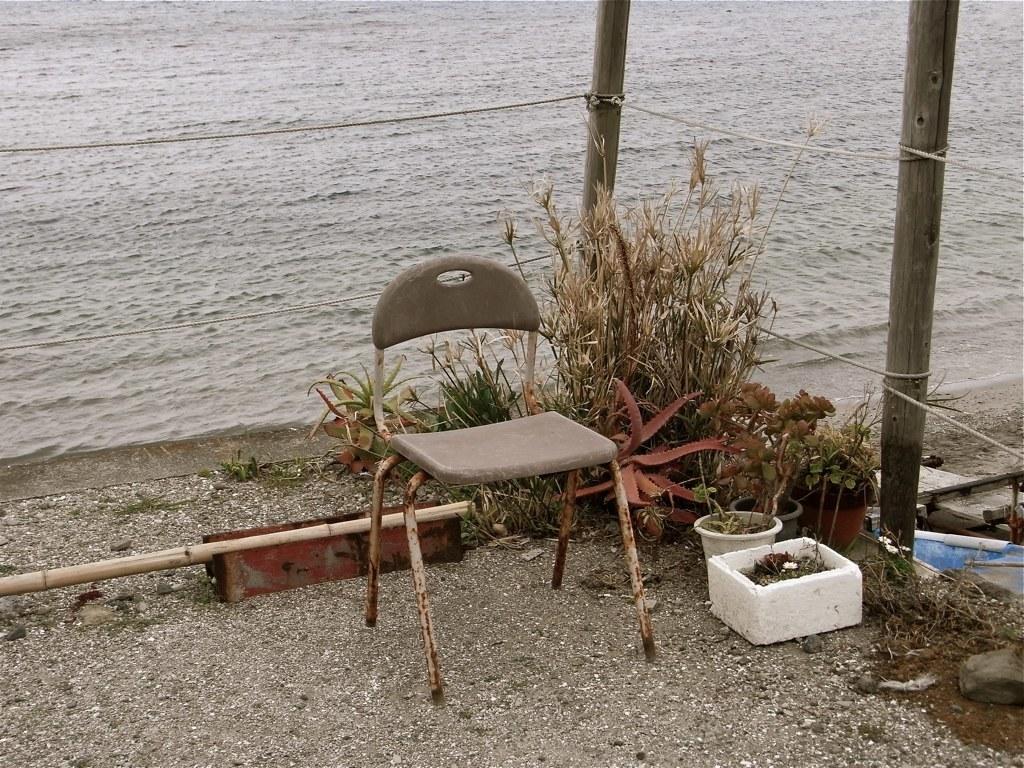How would you summarize this image in a sentence or two? In the picture we can see a path to it, we can see a chair near the chair we can see some plants and poles and some wires are tied to it, and in the background we can see water. 